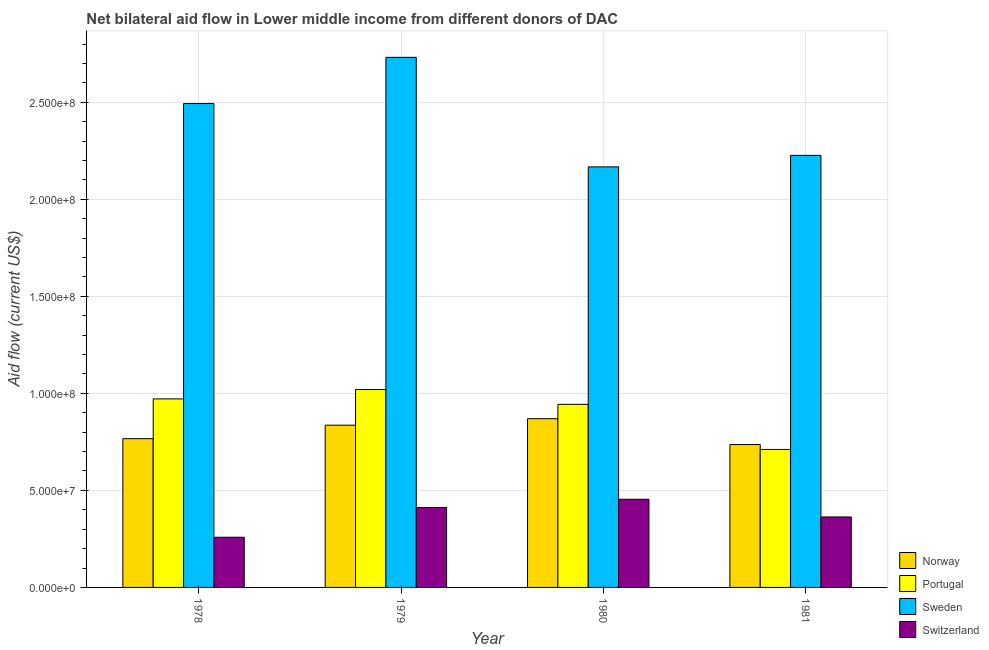Are the number of bars on each tick of the X-axis equal?
Provide a succinct answer. Yes. How many bars are there on the 1st tick from the left?
Offer a very short reply. 4. How many bars are there on the 3rd tick from the right?
Keep it short and to the point. 4. What is the label of the 1st group of bars from the left?
Provide a succinct answer. 1978. What is the amount of aid given by sweden in 1980?
Offer a terse response. 2.17e+08. Across all years, what is the maximum amount of aid given by sweden?
Provide a succinct answer. 2.73e+08. Across all years, what is the minimum amount of aid given by portugal?
Your answer should be very brief. 7.11e+07. In which year was the amount of aid given by norway maximum?
Offer a terse response. 1980. In which year was the amount of aid given by portugal minimum?
Give a very brief answer. 1981. What is the total amount of aid given by portugal in the graph?
Your response must be concise. 3.65e+08. What is the difference between the amount of aid given by sweden in 1978 and that in 1980?
Your response must be concise. 3.26e+07. What is the difference between the amount of aid given by sweden in 1981 and the amount of aid given by portugal in 1980?
Provide a succinct answer. 5.93e+06. What is the average amount of aid given by norway per year?
Offer a very short reply. 8.02e+07. What is the ratio of the amount of aid given by switzerland in 1980 to that in 1981?
Make the answer very short. 1.25. What is the difference between the highest and the second highest amount of aid given by switzerland?
Provide a short and direct response. 4.23e+06. What is the difference between the highest and the lowest amount of aid given by sweden?
Make the answer very short. 5.64e+07. In how many years, is the amount of aid given by sweden greater than the average amount of aid given by sweden taken over all years?
Make the answer very short. 2. What does the 2nd bar from the left in 1980 represents?
Your response must be concise. Portugal. What does the 4th bar from the right in 1980 represents?
Your response must be concise. Norway. Are all the bars in the graph horizontal?
Your answer should be compact. No. What is the difference between two consecutive major ticks on the Y-axis?
Keep it short and to the point. 5.00e+07. Are the values on the major ticks of Y-axis written in scientific E-notation?
Keep it short and to the point. Yes. Where does the legend appear in the graph?
Ensure brevity in your answer.  Bottom right. How many legend labels are there?
Your answer should be compact. 4. How are the legend labels stacked?
Give a very brief answer. Vertical. What is the title of the graph?
Offer a very short reply. Net bilateral aid flow in Lower middle income from different donors of DAC. Does "Quality of logistic services" appear as one of the legend labels in the graph?
Your response must be concise. No. What is the label or title of the X-axis?
Offer a very short reply. Year. What is the Aid flow (current US$) in Norway in 1978?
Your answer should be very brief. 7.66e+07. What is the Aid flow (current US$) in Portugal in 1978?
Your answer should be compact. 9.71e+07. What is the Aid flow (current US$) of Sweden in 1978?
Your answer should be very brief. 2.49e+08. What is the Aid flow (current US$) in Switzerland in 1978?
Provide a short and direct response. 2.58e+07. What is the Aid flow (current US$) of Norway in 1979?
Give a very brief answer. 8.36e+07. What is the Aid flow (current US$) of Portugal in 1979?
Your answer should be very brief. 1.02e+08. What is the Aid flow (current US$) in Sweden in 1979?
Your response must be concise. 2.73e+08. What is the Aid flow (current US$) in Switzerland in 1979?
Make the answer very short. 4.12e+07. What is the Aid flow (current US$) of Norway in 1980?
Ensure brevity in your answer.  8.70e+07. What is the Aid flow (current US$) of Portugal in 1980?
Offer a terse response. 9.43e+07. What is the Aid flow (current US$) in Sweden in 1980?
Make the answer very short. 2.17e+08. What is the Aid flow (current US$) of Switzerland in 1980?
Give a very brief answer. 4.54e+07. What is the Aid flow (current US$) in Norway in 1981?
Your answer should be compact. 7.36e+07. What is the Aid flow (current US$) in Portugal in 1981?
Provide a succinct answer. 7.11e+07. What is the Aid flow (current US$) of Sweden in 1981?
Offer a very short reply. 2.23e+08. What is the Aid flow (current US$) in Switzerland in 1981?
Make the answer very short. 3.63e+07. Across all years, what is the maximum Aid flow (current US$) of Norway?
Your answer should be compact. 8.70e+07. Across all years, what is the maximum Aid flow (current US$) of Portugal?
Give a very brief answer. 1.02e+08. Across all years, what is the maximum Aid flow (current US$) in Sweden?
Ensure brevity in your answer.  2.73e+08. Across all years, what is the maximum Aid flow (current US$) in Switzerland?
Your answer should be very brief. 4.54e+07. Across all years, what is the minimum Aid flow (current US$) in Norway?
Make the answer very short. 7.36e+07. Across all years, what is the minimum Aid flow (current US$) of Portugal?
Give a very brief answer. 7.11e+07. Across all years, what is the minimum Aid flow (current US$) of Sweden?
Keep it short and to the point. 2.17e+08. Across all years, what is the minimum Aid flow (current US$) of Switzerland?
Ensure brevity in your answer.  2.58e+07. What is the total Aid flow (current US$) of Norway in the graph?
Give a very brief answer. 3.21e+08. What is the total Aid flow (current US$) of Portugal in the graph?
Your response must be concise. 3.65e+08. What is the total Aid flow (current US$) in Sweden in the graph?
Make the answer very short. 9.62e+08. What is the total Aid flow (current US$) of Switzerland in the graph?
Offer a terse response. 1.49e+08. What is the difference between the Aid flow (current US$) of Norway in 1978 and that in 1979?
Provide a short and direct response. -6.96e+06. What is the difference between the Aid flow (current US$) of Portugal in 1978 and that in 1979?
Ensure brevity in your answer.  -4.83e+06. What is the difference between the Aid flow (current US$) of Sweden in 1978 and that in 1979?
Provide a succinct answer. -2.38e+07. What is the difference between the Aid flow (current US$) in Switzerland in 1978 and that in 1979?
Provide a succinct answer. -1.53e+07. What is the difference between the Aid flow (current US$) in Norway in 1978 and that in 1980?
Provide a short and direct response. -1.03e+07. What is the difference between the Aid flow (current US$) in Portugal in 1978 and that in 1980?
Provide a short and direct response. 2.81e+06. What is the difference between the Aid flow (current US$) in Sweden in 1978 and that in 1980?
Your response must be concise. 3.26e+07. What is the difference between the Aid flow (current US$) of Switzerland in 1978 and that in 1980?
Your response must be concise. -1.96e+07. What is the difference between the Aid flow (current US$) of Norway in 1978 and that in 1981?
Your response must be concise. 3.02e+06. What is the difference between the Aid flow (current US$) in Portugal in 1978 and that in 1981?
Offer a terse response. 2.60e+07. What is the difference between the Aid flow (current US$) in Sweden in 1978 and that in 1981?
Provide a succinct answer. 2.67e+07. What is the difference between the Aid flow (current US$) in Switzerland in 1978 and that in 1981?
Offer a terse response. -1.05e+07. What is the difference between the Aid flow (current US$) in Norway in 1979 and that in 1980?
Your answer should be very brief. -3.35e+06. What is the difference between the Aid flow (current US$) in Portugal in 1979 and that in 1980?
Ensure brevity in your answer.  7.64e+06. What is the difference between the Aid flow (current US$) in Sweden in 1979 and that in 1980?
Provide a succinct answer. 5.64e+07. What is the difference between the Aid flow (current US$) in Switzerland in 1979 and that in 1980?
Make the answer very short. -4.23e+06. What is the difference between the Aid flow (current US$) of Norway in 1979 and that in 1981?
Your answer should be very brief. 9.98e+06. What is the difference between the Aid flow (current US$) of Portugal in 1979 and that in 1981?
Make the answer very short. 3.09e+07. What is the difference between the Aid flow (current US$) of Sweden in 1979 and that in 1981?
Give a very brief answer. 5.05e+07. What is the difference between the Aid flow (current US$) of Switzerland in 1979 and that in 1981?
Offer a terse response. 4.86e+06. What is the difference between the Aid flow (current US$) in Norway in 1980 and that in 1981?
Give a very brief answer. 1.33e+07. What is the difference between the Aid flow (current US$) of Portugal in 1980 and that in 1981?
Give a very brief answer. 2.32e+07. What is the difference between the Aid flow (current US$) of Sweden in 1980 and that in 1981?
Provide a short and direct response. -5.93e+06. What is the difference between the Aid flow (current US$) of Switzerland in 1980 and that in 1981?
Make the answer very short. 9.09e+06. What is the difference between the Aid flow (current US$) of Norway in 1978 and the Aid flow (current US$) of Portugal in 1979?
Offer a very short reply. -2.53e+07. What is the difference between the Aid flow (current US$) in Norway in 1978 and the Aid flow (current US$) in Sweden in 1979?
Ensure brevity in your answer.  -1.96e+08. What is the difference between the Aid flow (current US$) of Norway in 1978 and the Aid flow (current US$) of Switzerland in 1979?
Make the answer very short. 3.55e+07. What is the difference between the Aid flow (current US$) of Portugal in 1978 and the Aid flow (current US$) of Sweden in 1979?
Your response must be concise. -1.76e+08. What is the difference between the Aid flow (current US$) of Portugal in 1978 and the Aid flow (current US$) of Switzerland in 1979?
Keep it short and to the point. 5.60e+07. What is the difference between the Aid flow (current US$) of Sweden in 1978 and the Aid flow (current US$) of Switzerland in 1979?
Provide a succinct answer. 2.08e+08. What is the difference between the Aid flow (current US$) in Norway in 1978 and the Aid flow (current US$) in Portugal in 1980?
Make the answer very short. -1.77e+07. What is the difference between the Aid flow (current US$) of Norway in 1978 and the Aid flow (current US$) of Sweden in 1980?
Your answer should be very brief. -1.40e+08. What is the difference between the Aid flow (current US$) of Norway in 1978 and the Aid flow (current US$) of Switzerland in 1980?
Provide a succinct answer. 3.12e+07. What is the difference between the Aid flow (current US$) of Portugal in 1978 and the Aid flow (current US$) of Sweden in 1980?
Offer a terse response. -1.20e+08. What is the difference between the Aid flow (current US$) of Portugal in 1978 and the Aid flow (current US$) of Switzerland in 1980?
Make the answer very short. 5.17e+07. What is the difference between the Aid flow (current US$) of Sweden in 1978 and the Aid flow (current US$) of Switzerland in 1980?
Ensure brevity in your answer.  2.04e+08. What is the difference between the Aid flow (current US$) in Norway in 1978 and the Aid flow (current US$) in Portugal in 1981?
Your answer should be very brief. 5.54e+06. What is the difference between the Aid flow (current US$) of Norway in 1978 and the Aid flow (current US$) of Sweden in 1981?
Your answer should be compact. -1.46e+08. What is the difference between the Aid flow (current US$) in Norway in 1978 and the Aid flow (current US$) in Switzerland in 1981?
Offer a terse response. 4.03e+07. What is the difference between the Aid flow (current US$) of Portugal in 1978 and the Aid flow (current US$) of Sweden in 1981?
Give a very brief answer. -1.25e+08. What is the difference between the Aid flow (current US$) in Portugal in 1978 and the Aid flow (current US$) in Switzerland in 1981?
Keep it short and to the point. 6.08e+07. What is the difference between the Aid flow (current US$) of Sweden in 1978 and the Aid flow (current US$) of Switzerland in 1981?
Your answer should be very brief. 2.13e+08. What is the difference between the Aid flow (current US$) of Norway in 1979 and the Aid flow (current US$) of Portugal in 1980?
Your answer should be very brief. -1.07e+07. What is the difference between the Aid flow (current US$) in Norway in 1979 and the Aid flow (current US$) in Sweden in 1980?
Your response must be concise. -1.33e+08. What is the difference between the Aid flow (current US$) in Norway in 1979 and the Aid flow (current US$) in Switzerland in 1980?
Give a very brief answer. 3.82e+07. What is the difference between the Aid flow (current US$) of Portugal in 1979 and the Aid flow (current US$) of Sweden in 1980?
Offer a terse response. -1.15e+08. What is the difference between the Aid flow (current US$) of Portugal in 1979 and the Aid flow (current US$) of Switzerland in 1980?
Make the answer very short. 5.66e+07. What is the difference between the Aid flow (current US$) of Sweden in 1979 and the Aid flow (current US$) of Switzerland in 1980?
Your answer should be compact. 2.28e+08. What is the difference between the Aid flow (current US$) of Norway in 1979 and the Aid flow (current US$) of Portugal in 1981?
Provide a short and direct response. 1.25e+07. What is the difference between the Aid flow (current US$) in Norway in 1979 and the Aid flow (current US$) in Sweden in 1981?
Offer a terse response. -1.39e+08. What is the difference between the Aid flow (current US$) in Norway in 1979 and the Aid flow (current US$) in Switzerland in 1981?
Ensure brevity in your answer.  4.73e+07. What is the difference between the Aid flow (current US$) of Portugal in 1979 and the Aid flow (current US$) of Sweden in 1981?
Offer a very short reply. -1.21e+08. What is the difference between the Aid flow (current US$) of Portugal in 1979 and the Aid flow (current US$) of Switzerland in 1981?
Give a very brief answer. 6.56e+07. What is the difference between the Aid flow (current US$) in Sweden in 1979 and the Aid flow (current US$) in Switzerland in 1981?
Provide a short and direct response. 2.37e+08. What is the difference between the Aid flow (current US$) of Norway in 1980 and the Aid flow (current US$) of Portugal in 1981?
Your answer should be compact. 1.58e+07. What is the difference between the Aid flow (current US$) in Norway in 1980 and the Aid flow (current US$) in Sweden in 1981?
Ensure brevity in your answer.  -1.36e+08. What is the difference between the Aid flow (current US$) of Norway in 1980 and the Aid flow (current US$) of Switzerland in 1981?
Provide a short and direct response. 5.06e+07. What is the difference between the Aid flow (current US$) of Portugal in 1980 and the Aid flow (current US$) of Sweden in 1981?
Keep it short and to the point. -1.28e+08. What is the difference between the Aid flow (current US$) of Portugal in 1980 and the Aid flow (current US$) of Switzerland in 1981?
Ensure brevity in your answer.  5.80e+07. What is the difference between the Aid flow (current US$) in Sweden in 1980 and the Aid flow (current US$) in Switzerland in 1981?
Offer a terse response. 1.80e+08. What is the average Aid flow (current US$) in Norway per year?
Offer a terse response. 8.02e+07. What is the average Aid flow (current US$) of Portugal per year?
Ensure brevity in your answer.  9.11e+07. What is the average Aid flow (current US$) in Sweden per year?
Your response must be concise. 2.40e+08. What is the average Aid flow (current US$) in Switzerland per year?
Your response must be concise. 3.72e+07. In the year 1978, what is the difference between the Aid flow (current US$) in Norway and Aid flow (current US$) in Portugal?
Keep it short and to the point. -2.05e+07. In the year 1978, what is the difference between the Aid flow (current US$) of Norway and Aid flow (current US$) of Sweden?
Offer a terse response. -1.73e+08. In the year 1978, what is the difference between the Aid flow (current US$) of Norway and Aid flow (current US$) of Switzerland?
Ensure brevity in your answer.  5.08e+07. In the year 1978, what is the difference between the Aid flow (current US$) of Portugal and Aid flow (current US$) of Sweden?
Ensure brevity in your answer.  -1.52e+08. In the year 1978, what is the difference between the Aid flow (current US$) of Portugal and Aid flow (current US$) of Switzerland?
Your answer should be compact. 7.13e+07. In the year 1978, what is the difference between the Aid flow (current US$) in Sweden and Aid flow (current US$) in Switzerland?
Your response must be concise. 2.23e+08. In the year 1979, what is the difference between the Aid flow (current US$) of Norway and Aid flow (current US$) of Portugal?
Offer a very short reply. -1.84e+07. In the year 1979, what is the difference between the Aid flow (current US$) in Norway and Aid flow (current US$) in Sweden?
Offer a very short reply. -1.90e+08. In the year 1979, what is the difference between the Aid flow (current US$) of Norway and Aid flow (current US$) of Switzerland?
Provide a succinct answer. 4.24e+07. In the year 1979, what is the difference between the Aid flow (current US$) of Portugal and Aid flow (current US$) of Sweden?
Ensure brevity in your answer.  -1.71e+08. In the year 1979, what is the difference between the Aid flow (current US$) of Portugal and Aid flow (current US$) of Switzerland?
Provide a succinct answer. 6.08e+07. In the year 1979, what is the difference between the Aid flow (current US$) in Sweden and Aid flow (current US$) in Switzerland?
Provide a short and direct response. 2.32e+08. In the year 1980, what is the difference between the Aid flow (current US$) in Norway and Aid flow (current US$) in Portugal?
Offer a very short reply. -7.38e+06. In the year 1980, what is the difference between the Aid flow (current US$) in Norway and Aid flow (current US$) in Sweden?
Give a very brief answer. -1.30e+08. In the year 1980, what is the difference between the Aid flow (current US$) in Norway and Aid flow (current US$) in Switzerland?
Give a very brief answer. 4.15e+07. In the year 1980, what is the difference between the Aid flow (current US$) in Portugal and Aid flow (current US$) in Sweden?
Offer a very short reply. -1.22e+08. In the year 1980, what is the difference between the Aid flow (current US$) in Portugal and Aid flow (current US$) in Switzerland?
Offer a terse response. 4.89e+07. In the year 1980, what is the difference between the Aid flow (current US$) in Sweden and Aid flow (current US$) in Switzerland?
Make the answer very short. 1.71e+08. In the year 1981, what is the difference between the Aid flow (current US$) of Norway and Aid flow (current US$) of Portugal?
Your answer should be compact. 2.52e+06. In the year 1981, what is the difference between the Aid flow (current US$) of Norway and Aid flow (current US$) of Sweden?
Your answer should be very brief. -1.49e+08. In the year 1981, what is the difference between the Aid flow (current US$) in Norway and Aid flow (current US$) in Switzerland?
Your answer should be compact. 3.73e+07. In the year 1981, what is the difference between the Aid flow (current US$) in Portugal and Aid flow (current US$) in Sweden?
Provide a succinct answer. -1.52e+08. In the year 1981, what is the difference between the Aid flow (current US$) of Portugal and Aid flow (current US$) of Switzerland?
Give a very brief answer. 3.48e+07. In the year 1981, what is the difference between the Aid flow (current US$) of Sweden and Aid flow (current US$) of Switzerland?
Offer a very short reply. 1.86e+08. What is the ratio of the Aid flow (current US$) in Norway in 1978 to that in 1979?
Provide a short and direct response. 0.92. What is the ratio of the Aid flow (current US$) in Portugal in 1978 to that in 1979?
Offer a very short reply. 0.95. What is the ratio of the Aid flow (current US$) of Sweden in 1978 to that in 1979?
Ensure brevity in your answer.  0.91. What is the ratio of the Aid flow (current US$) in Switzerland in 1978 to that in 1979?
Your answer should be very brief. 0.63. What is the ratio of the Aid flow (current US$) of Norway in 1978 to that in 1980?
Your answer should be very brief. 0.88. What is the ratio of the Aid flow (current US$) in Portugal in 1978 to that in 1980?
Keep it short and to the point. 1.03. What is the ratio of the Aid flow (current US$) of Sweden in 1978 to that in 1980?
Ensure brevity in your answer.  1.15. What is the ratio of the Aid flow (current US$) of Switzerland in 1978 to that in 1980?
Provide a succinct answer. 0.57. What is the ratio of the Aid flow (current US$) of Norway in 1978 to that in 1981?
Ensure brevity in your answer.  1.04. What is the ratio of the Aid flow (current US$) of Portugal in 1978 to that in 1981?
Your response must be concise. 1.37. What is the ratio of the Aid flow (current US$) of Sweden in 1978 to that in 1981?
Your answer should be compact. 1.12. What is the ratio of the Aid flow (current US$) in Switzerland in 1978 to that in 1981?
Your response must be concise. 0.71. What is the ratio of the Aid flow (current US$) of Norway in 1979 to that in 1980?
Your response must be concise. 0.96. What is the ratio of the Aid flow (current US$) in Portugal in 1979 to that in 1980?
Your answer should be very brief. 1.08. What is the ratio of the Aid flow (current US$) of Sweden in 1979 to that in 1980?
Make the answer very short. 1.26. What is the ratio of the Aid flow (current US$) of Switzerland in 1979 to that in 1980?
Give a very brief answer. 0.91. What is the ratio of the Aid flow (current US$) of Norway in 1979 to that in 1981?
Make the answer very short. 1.14. What is the ratio of the Aid flow (current US$) of Portugal in 1979 to that in 1981?
Offer a terse response. 1.43. What is the ratio of the Aid flow (current US$) of Sweden in 1979 to that in 1981?
Your answer should be very brief. 1.23. What is the ratio of the Aid flow (current US$) of Switzerland in 1979 to that in 1981?
Offer a terse response. 1.13. What is the ratio of the Aid flow (current US$) of Norway in 1980 to that in 1981?
Offer a very short reply. 1.18. What is the ratio of the Aid flow (current US$) in Portugal in 1980 to that in 1981?
Offer a terse response. 1.33. What is the ratio of the Aid flow (current US$) in Sweden in 1980 to that in 1981?
Your response must be concise. 0.97. What is the ratio of the Aid flow (current US$) of Switzerland in 1980 to that in 1981?
Offer a terse response. 1.25. What is the difference between the highest and the second highest Aid flow (current US$) in Norway?
Offer a terse response. 3.35e+06. What is the difference between the highest and the second highest Aid flow (current US$) in Portugal?
Your answer should be compact. 4.83e+06. What is the difference between the highest and the second highest Aid flow (current US$) in Sweden?
Provide a short and direct response. 2.38e+07. What is the difference between the highest and the second highest Aid flow (current US$) of Switzerland?
Your answer should be compact. 4.23e+06. What is the difference between the highest and the lowest Aid flow (current US$) in Norway?
Ensure brevity in your answer.  1.33e+07. What is the difference between the highest and the lowest Aid flow (current US$) in Portugal?
Your answer should be very brief. 3.09e+07. What is the difference between the highest and the lowest Aid flow (current US$) in Sweden?
Your answer should be very brief. 5.64e+07. What is the difference between the highest and the lowest Aid flow (current US$) in Switzerland?
Make the answer very short. 1.96e+07. 